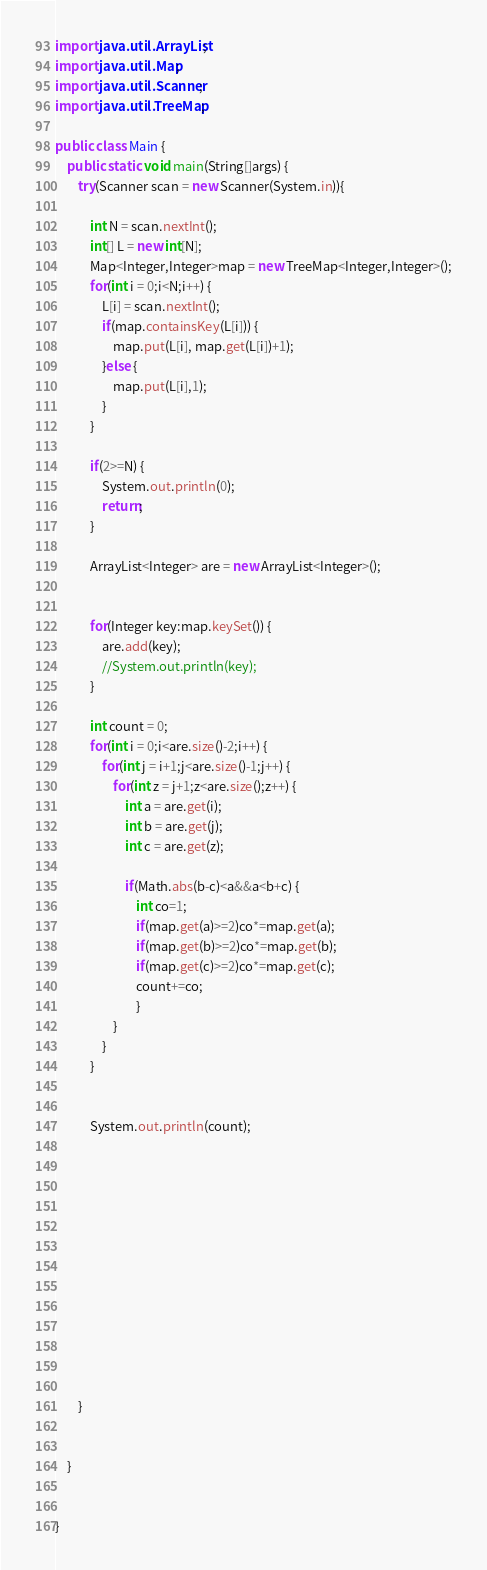<code> <loc_0><loc_0><loc_500><loc_500><_Java_>import java.util.ArrayList;
import java.util.Map;
import java.util.Scanner;
import java.util.TreeMap;

public class Main {
	public static void main(String[]args) {
		try(Scanner scan = new Scanner(System.in)){

			int N = scan.nextInt();
			int[] L = new int[N];
			Map<Integer,Integer>map = new TreeMap<Integer,Integer>();
			for(int i = 0;i<N;i++) {
				L[i] = scan.nextInt();
				if(map.containsKey(L[i])) {
					map.put(L[i], map.get(L[i])+1);
				}else {
					map.put(L[i],1);
				}
			}

			if(2>=N) {
				System.out.println(0);
				return;
			}

			ArrayList<Integer> are = new ArrayList<Integer>();


			for(Integer key:map.keySet()) {
				are.add(key);
				//System.out.println(key);
			}

			int count = 0;
			for(int i = 0;i<are.size()-2;i++) {
				for(int j = i+1;j<are.size()-1;j++) {
					for(int z = j+1;z<are.size();z++) {
						int a = are.get(i);
						int b = are.get(j);
						int c = are.get(z);

						if(Math.abs(b-c)<a&&a<b+c) {
							int co=1;
							if(map.get(a)>=2)co*=map.get(a);
							if(map.get(b)>=2)co*=map.get(b);
							if(map.get(c)>=2)co*=map.get(c);
							count+=co;
							}
					}
				}
			}


			System.out.println(count);













		}


	}


}
</code> 